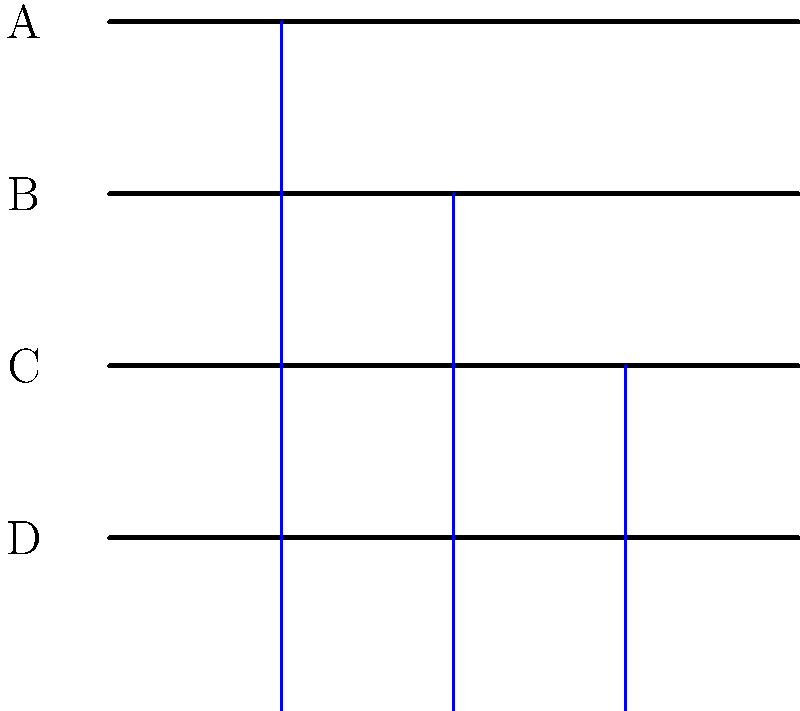Based on the series of wound closure diagrams labeled A through D, which sequence correctly represents the proper order of suture placement for closing a linear surgical incision? To properly close a linear surgical incision, sutures should be placed in a specific order to ensure even distribution of tension and optimal wound healing. Let's analyze the diagrams step-by-step:

1. Diagram A shows an open wound without any sutures. This is the starting point.

2. Diagram B shows the first suture placed in the middle of the wound. This is the correct first step as it helps to approximate the wound edges and provides a reference point for subsequent sutures.

3. Diagram C shows two sutures in place. The second suture is placed halfway between the first suture and one end of the wound. This follows the principle of halving the distances between sutures.

4. Diagram D shows the final step with three sutures in place. The third suture is placed halfway between the first suture and the other end of the wound.

This technique of placing sutures is known as the halving method. It ensures even distribution of tension across the wound and helps prevent complications such as wound dehiscence.

The correct sequence of suture placement is therefore:

A (open wound) → B (middle suture) → C (second suture) → D (third suture)

This order follows the principle of starting in the middle and working outwards, which is a standard technique in surgical wound closure.
Answer: A → B → C → D 